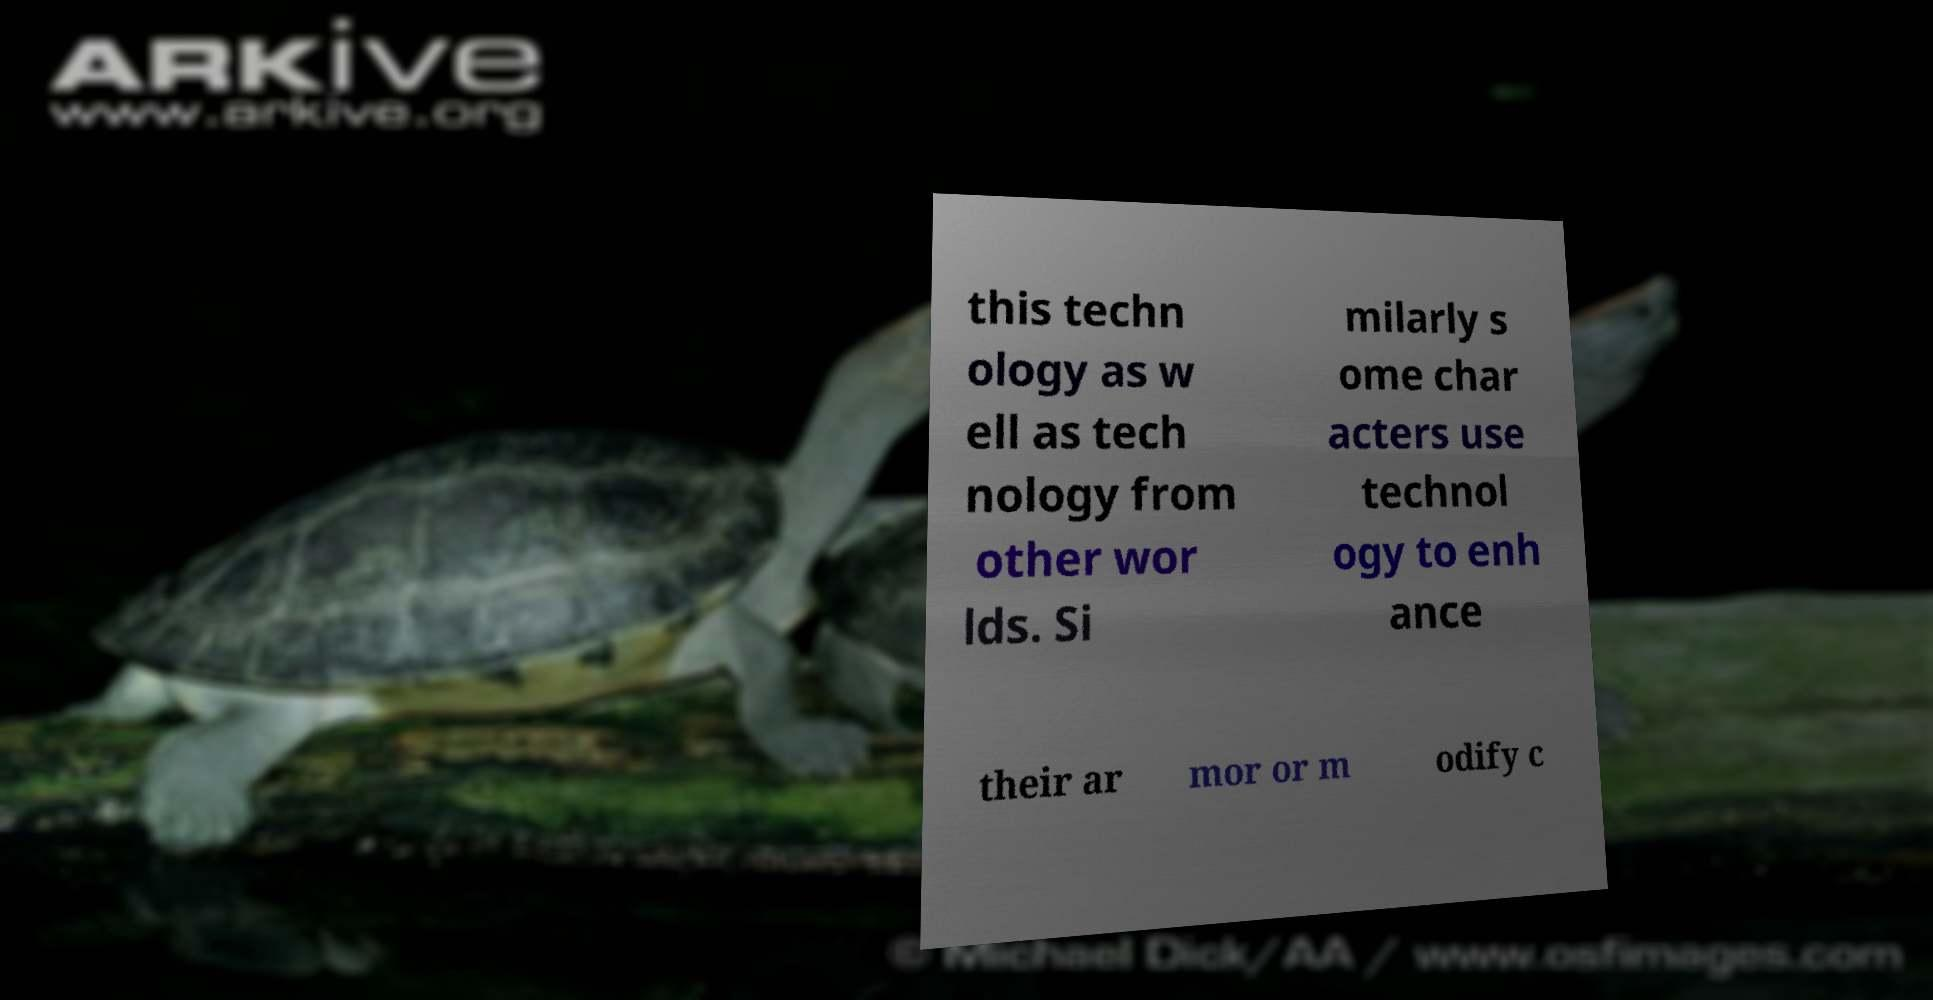I need the written content from this picture converted into text. Can you do that? this techn ology as w ell as tech nology from other wor lds. Si milarly s ome char acters use technol ogy to enh ance their ar mor or m odify c 